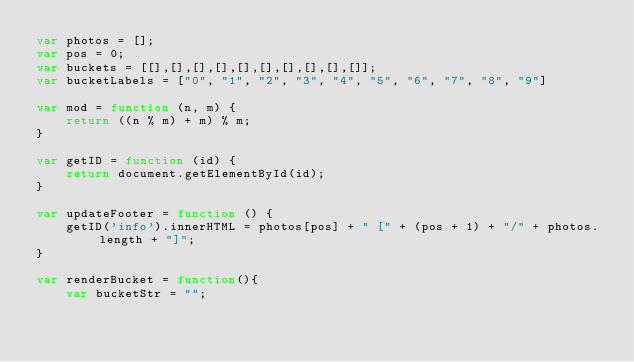Convert code to text. <code><loc_0><loc_0><loc_500><loc_500><_JavaScript_>var photos = [];
var pos = 0;
var buckets = [[],[],[],[],[],[],[],[],[],[]];
var bucketLabels = ["0", "1", "2", "3", "4", "5", "6", "7", "8", "9"]

var mod = function (n, m) {
    return ((n % m) + m) % m;
}

var getID = function (id) {
    return document.getElementById(id);
}

var updateFooter = function () {
    getID('info').innerHTML = photos[pos] + " [" + (pos + 1) + "/" + photos.length + "]";
}

var renderBucket = function(){
    var bucketStr = "";</code> 